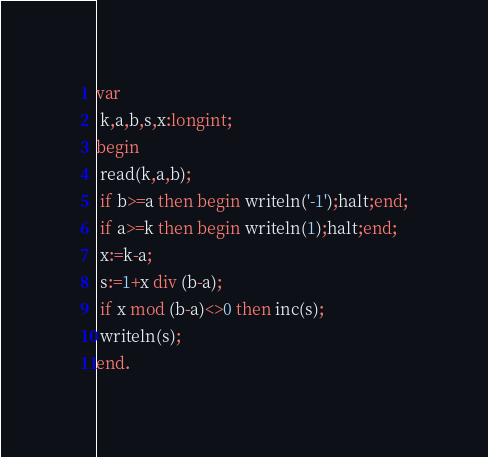Convert code to text. <code><loc_0><loc_0><loc_500><loc_500><_Pascal_>var
 k,a,b,s,x:longint;
begin
 read(k,a,b);
 if b>=a then begin writeln('-1');halt;end;
 if a>=k then begin writeln(1);halt;end;
 x:=k-a;
 s:=1+x div (b-a);
 if x mod (b-a)<>0 then inc(s);
 writeln(s);
end.</code> 